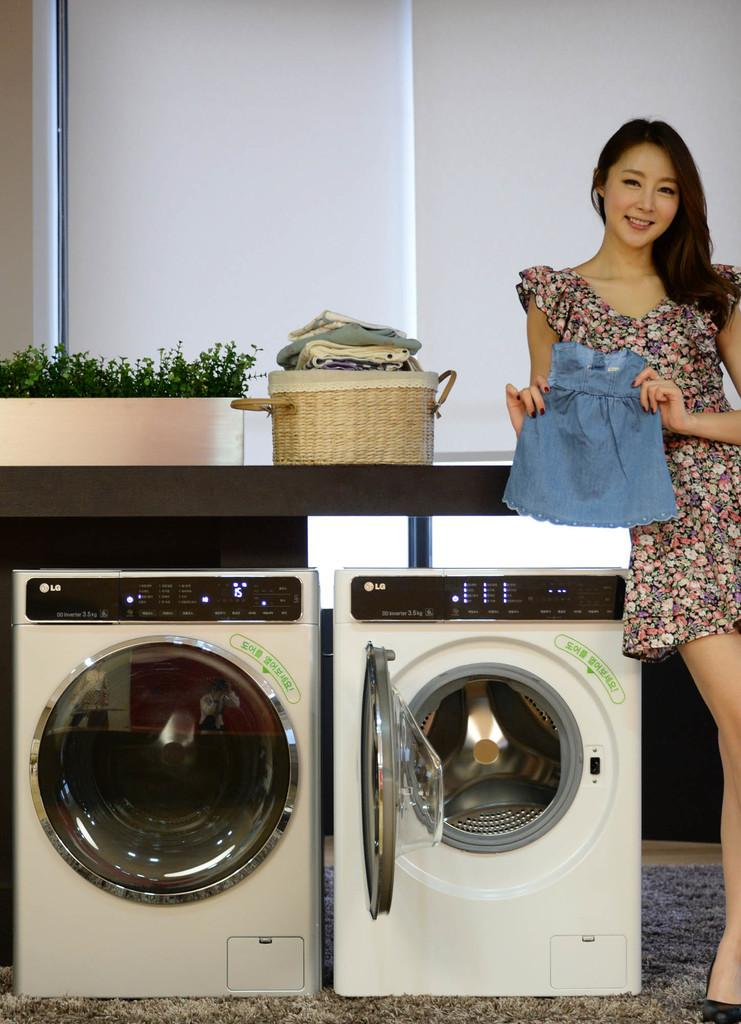<image>
Provide a brief description of the given image. A woman standing next to a set of washer and dryer while holding a denim shirt. 